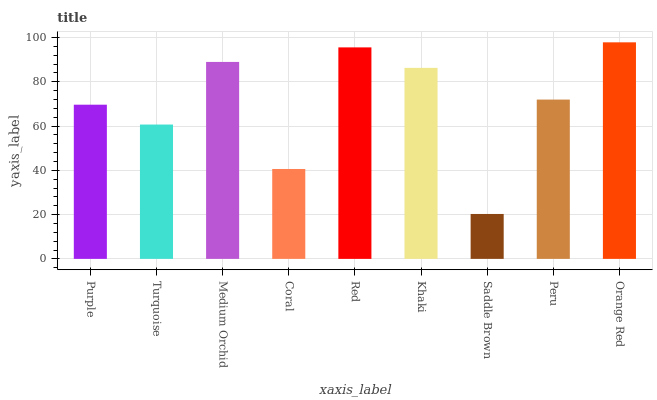Is Saddle Brown the minimum?
Answer yes or no. Yes. Is Orange Red the maximum?
Answer yes or no. Yes. Is Turquoise the minimum?
Answer yes or no. No. Is Turquoise the maximum?
Answer yes or no. No. Is Purple greater than Turquoise?
Answer yes or no. Yes. Is Turquoise less than Purple?
Answer yes or no. Yes. Is Turquoise greater than Purple?
Answer yes or no. No. Is Purple less than Turquoise?
Answer yes or no. No. Is Peru the high median?
Answer yes or no. Yes. Is Peru the low median?
Answer yes or no. Yes. Is Medium Orchid the high median?
Answer yes or no. No. Is Orange Red the low median?
Answer yes or no. No. 